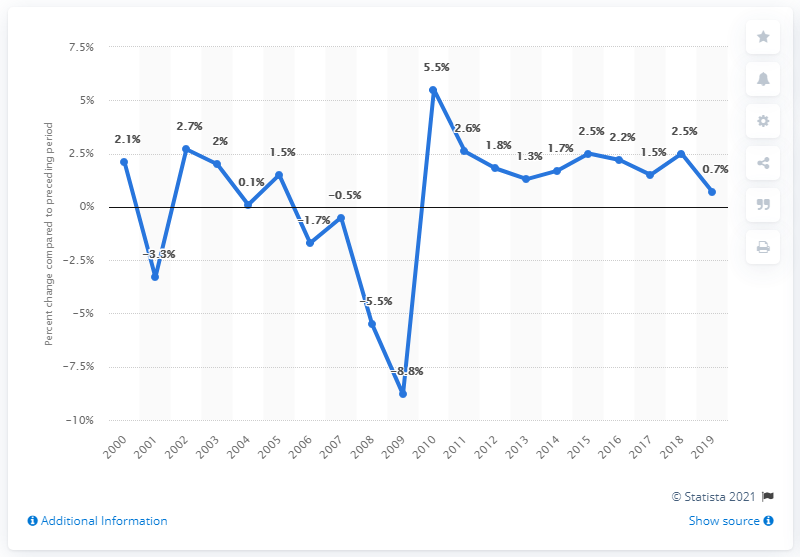Outline some significant characteristics in this image. Michigan's real GDP grew by 0.7% in 2019. 